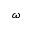<formula> <loc_0><loc_0><loc_500><loc_500>\omega</formula> 